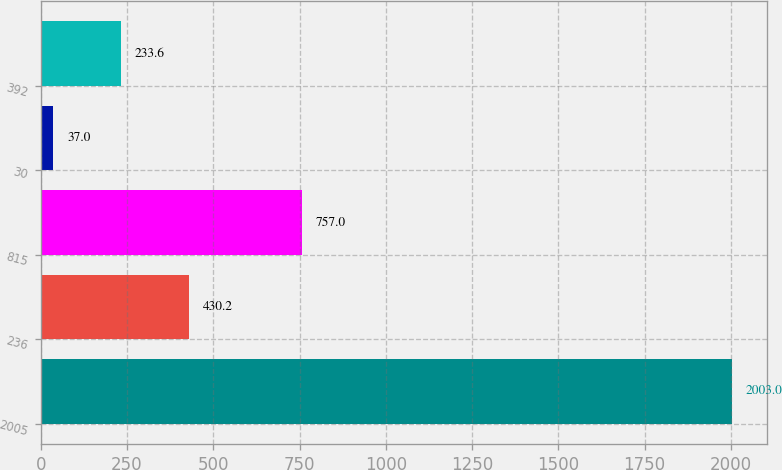Convert chart. <chart><loc_0><loc_0><loc_500><loc_500><bar_chart><fcel>2005<fcel>236<fcel>815<fcel>30<fcel>392<nl><fcel>2003<fcel>430.2<fcel>757<fcel>37<fcel>233.6<nl></chart> 